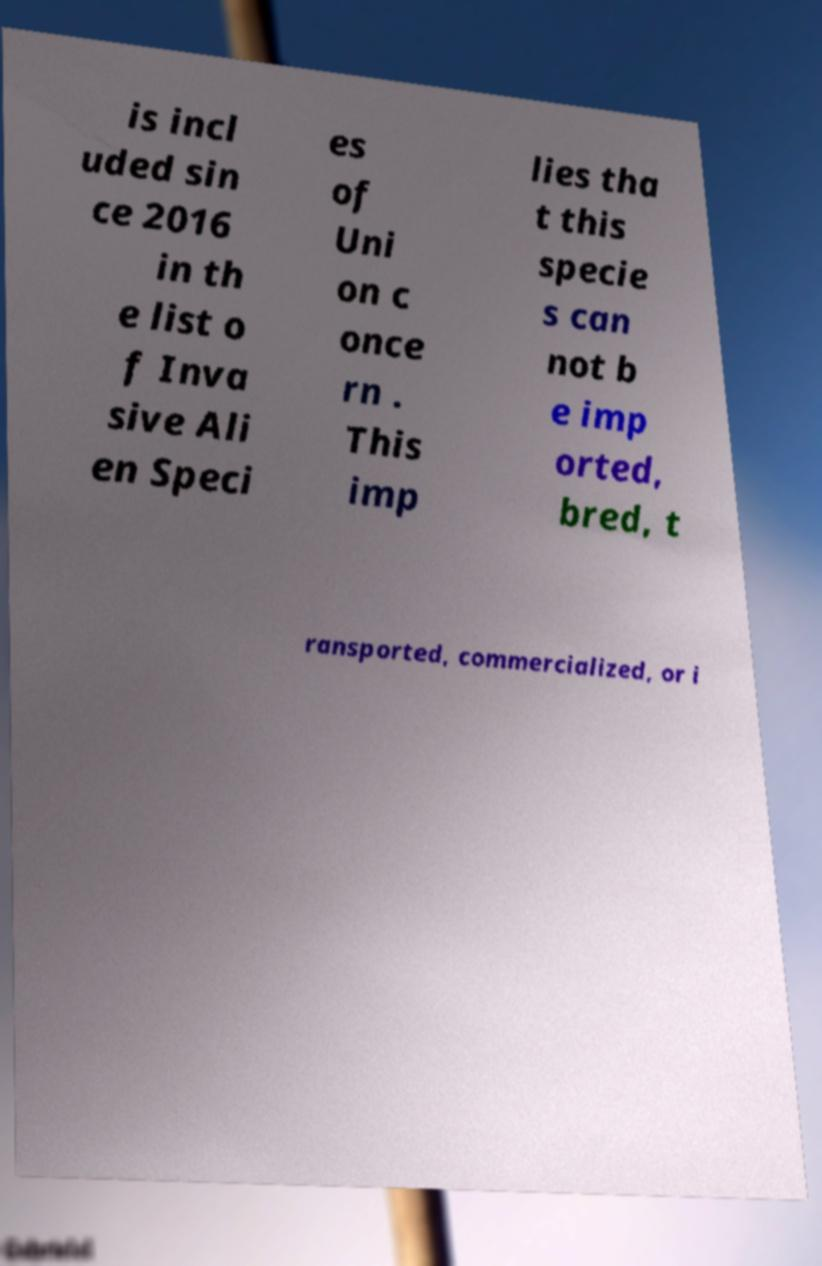Could you extract and type out the text from this image? is incl uded sin ce 2016 in th e list o f Inva sive Ali en Speci es of Uni on c once rn . This imp lies tha t this specie s can not b e imp orted, bred, t ransported, commercialized, or i 